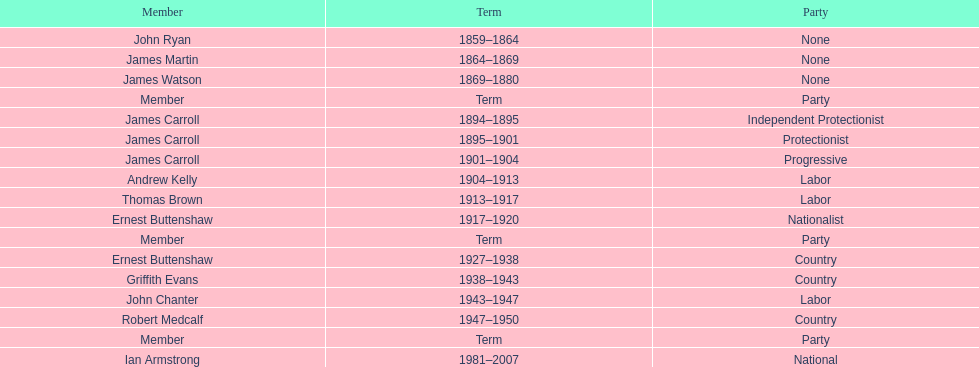How long did ian armstrong serve? 26 years. 